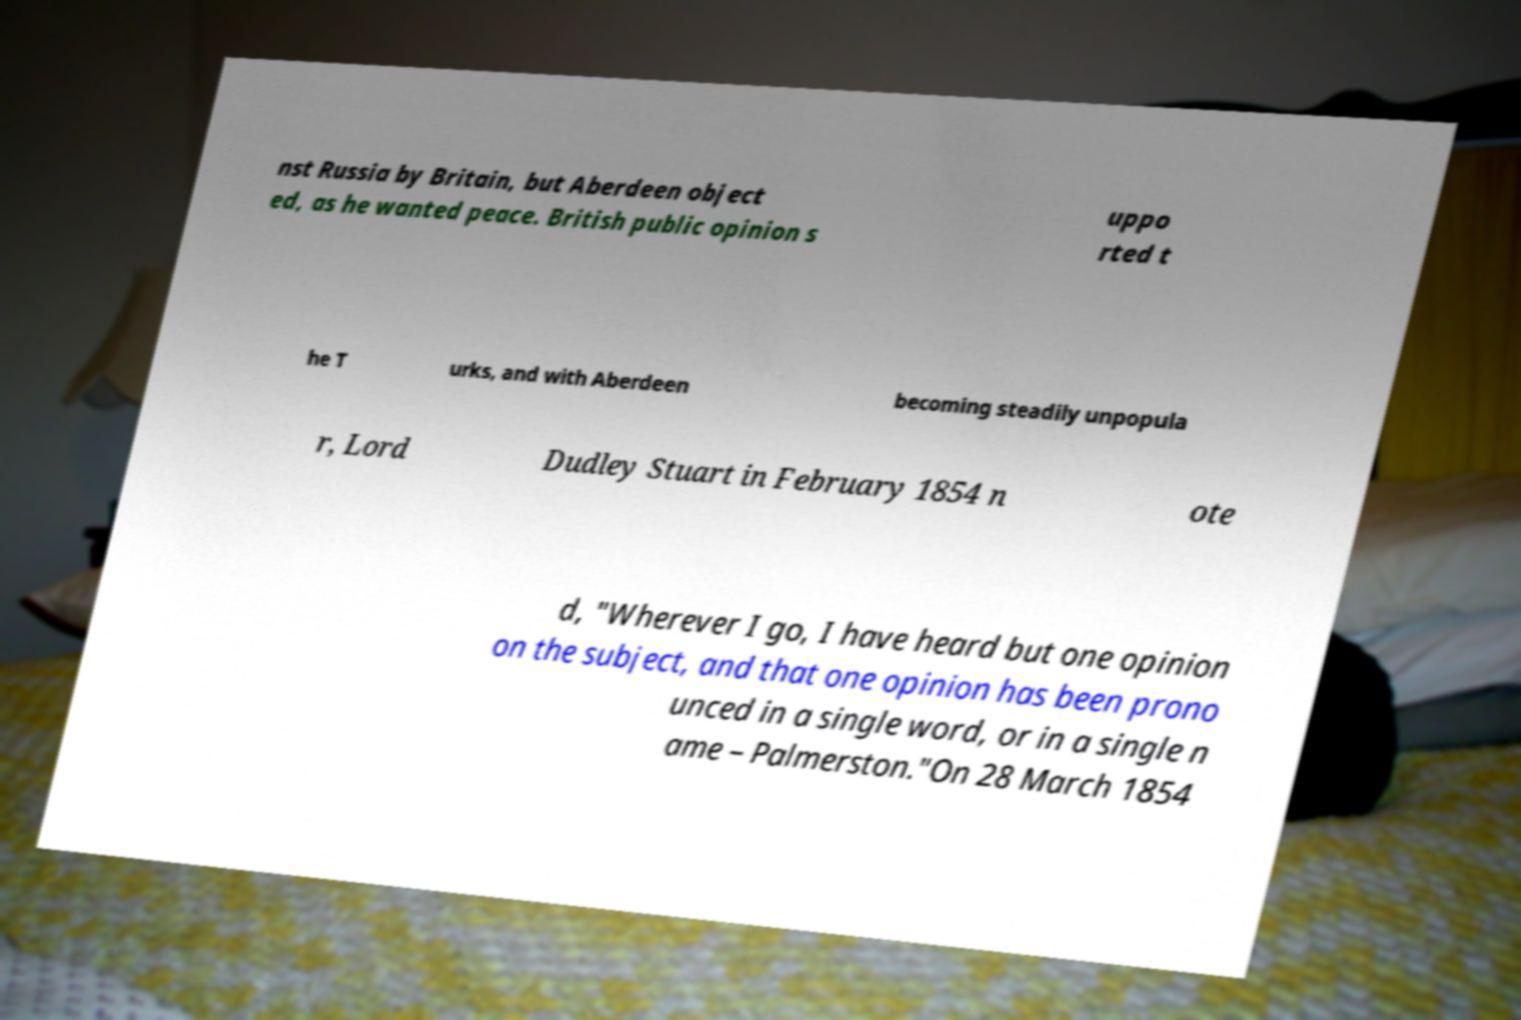For documentation purposes, I need the text within this image transcribed. Could you provide that? nst Russia by Britain, but Aberdeen object ed, as he wanted peace. British public opinion s uppo rted t he T urks, and with Aberdeen becoming steadily unpopula r, Lord Dudley Stuart in February 1854 n ote d, "Wherever I go, I have heard but one opinion on the subject, and that one opinion has been prono unced in a single word, or in a single n ame – Palmerston."On 28 March 1854 